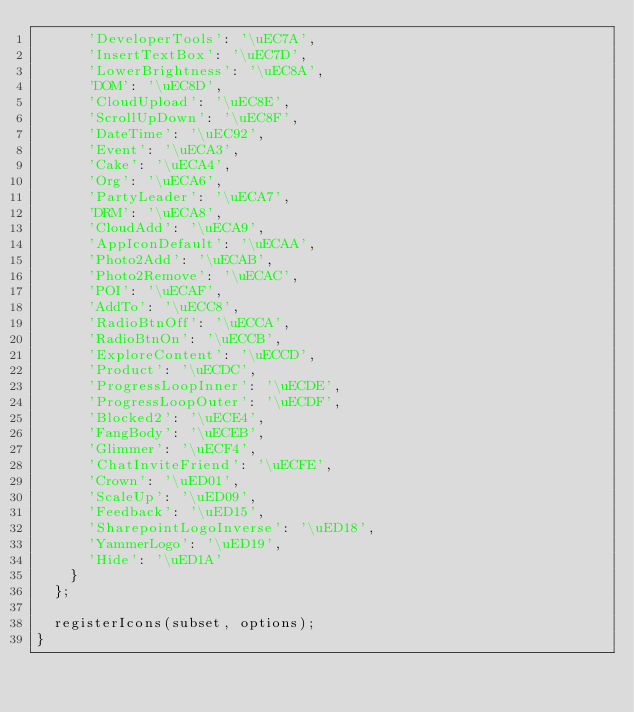Convert code to text. <code><loc_0><loc_0><loc_500><loc_500><_TypeScript_>      'DeveloperTools': '\uEC7A',
      'InsertTextBox': '\uEC7D',
      'LowerBrightness': '\uEC8A',
      'DOM': '\uEC8D',
      'CloudUpload': '\uEC8E',
      'ScrollUpDown': '\uEC8F',
      'DateTime': '\uEC92',
      'Event': '\uECA3',
      'Cake': '\uECA4',
      'Org': '\uECA6',
      'PartyLeader': '\uECA7',
      'DRM': '\uECA8',
      'CloudAdd': '\uECA9',
      'AppIconDefault': '\uECAA',
      'Photo2Add': '\uECAB',
      'Photo2Remove': '\uECAC',
      'POI': '\uECAF',
      'AddTo': '\uECC8',
      'RadioBtnOff': '\uECCA',
      'RadioBtnOn': '\uECCB',
      'ExploreContent': '\uECCD',
      'Product': '\uECDC',
      'ProgressLoopInner': '\uECDE',
      'ProgressLoopOuter': '\uECDF',
      'Blocked2': '\uECE4',
      'FangBody': '\uECEB',
      'Glimmer': '\uECF4',
      'ChatInviteFriend': '\uECFE',
      'Crown': '\uED01',
      'ScaleUp': '\uED09',
      'Feedback': '\uED15',
      'SharepointLogoInverse': '\uED18',
      'YammerLogo': '\uED19',
      'Hide': '\uED1A'
    }
  };

  registerIcons(subset, options);
}
</code> 